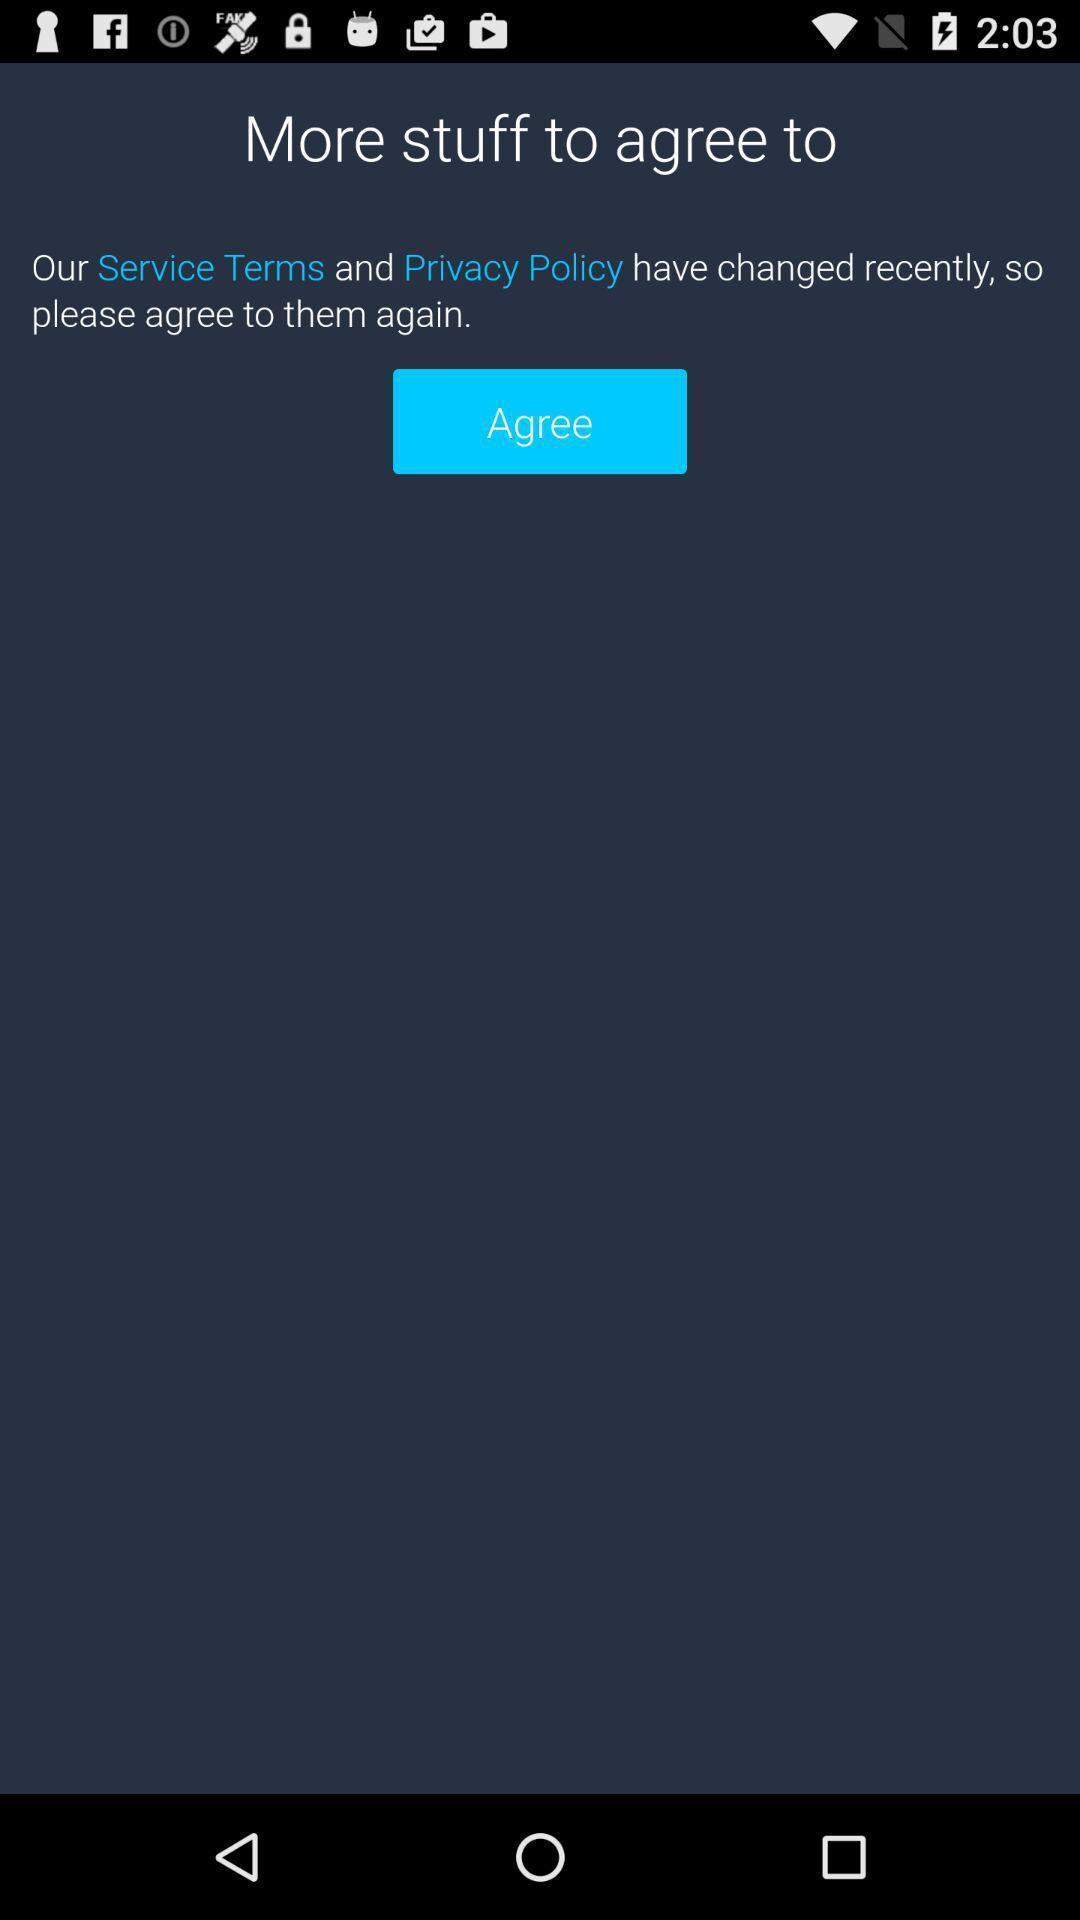Tell me what you see in this picture. Screen shows agree option. 